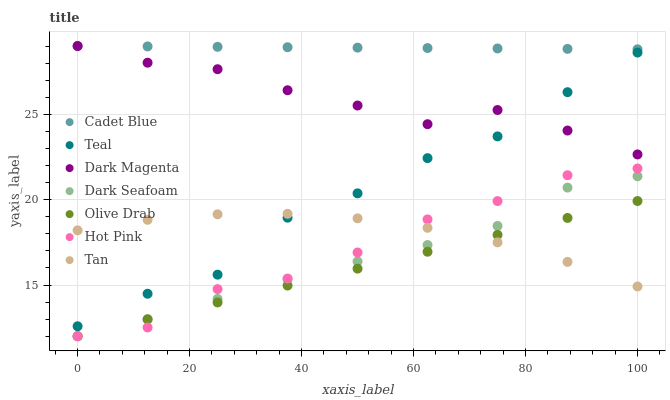Does Olive Drab have the minimum area under the curve?
Answer yes or no. Yes. Does Cadet Blue have the maximum area under the curve?
Answer yes or no. Yes. Does Dark Magenta have the minimum area under the curve?
Answer yes or no. No. Does Dark Magenta have the maximum area under the curve?
Answer yes or no. No. Is Olive Drab the smoothest?
Answer yes or no. Yes. Is Teal the roughest?
Answer yes or no. Yes. Is Dark Magenta the smoothest?
Answer yes or no. No. Is Dark Magenta the roughest?
Answer yes or no. No. Does Hot Pink have the lowest value?
Answer yes or no. Yes. Does Dark Magenta have the lowest value?
Answer yes or no. No. Does Dark Magenta have the highest value?
Answer yes or no. Yes. Does Hot Pink have the highest value?
Answer yes or no. No. Is Olive Drab less than Dark Magenta?
Answer yes or no. Yes. Is Cadet Blue greater than Hot Pink?
Answer yes or no. Yes. Does Dark Seafoam intersect Olive Drab?
Answer yes or no. Yes. Is Dark Seafoam less than Olive Drab?
Answer yes or no. No. Is Dark Seafoam greater than Olive Drab?
Answer yes or no. No. Does Olive Drab intersect Dark Magenta?
Answer yes or no. No. 